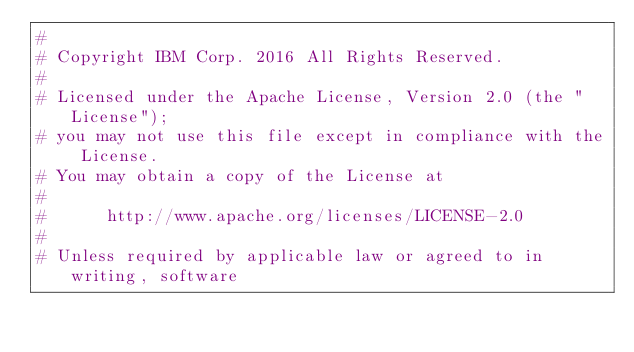<code> <loc_0><loc_0><loc_500><loc_500><_Python_>#
# Copyright IBM Corp. 2016 All Rights Reserved.
#
# Licensed under the Apache License, Version 2.0 (the "License");
# you may not use this file except in compliance with the License.
# You may obtain a copy of the License at
#
#      http://www.apache.org/licenses/LICENSE-2.0
#
# Unless required by applicable law or agreed to in writing, software</code> 